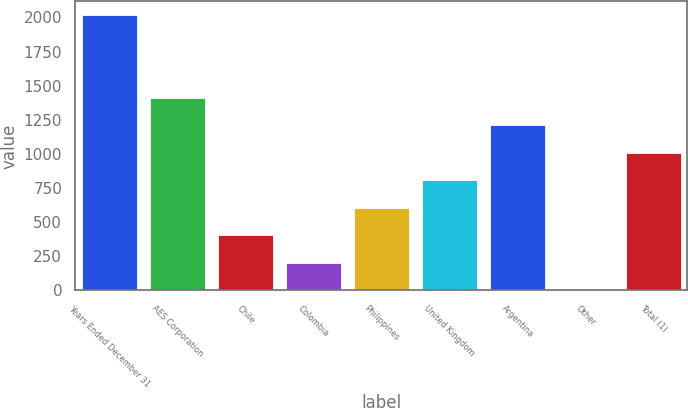<chart> <loc_0><loc_0><loc_500><loc_500><bar_chart><fcel>Years Ended December 31<fcel>AES Corporation<fcel>Chile<fcel>Colombia<fcel>Philippines<fcel>United Kingdom<fcel>Argentina<fcel>Other<fcel>Total (1)<nl><fcel>2016<fcel>1411.8<fcel>404.8<fcel>203.4<fcel>606.2<fcel>807.6<fcel>1210.4<fcel>2<fcel>1009<nl></chart> 